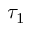<formula> <loc_0><loc_0><loc_500><loc_500>\tau _ { 1 }</formula> 